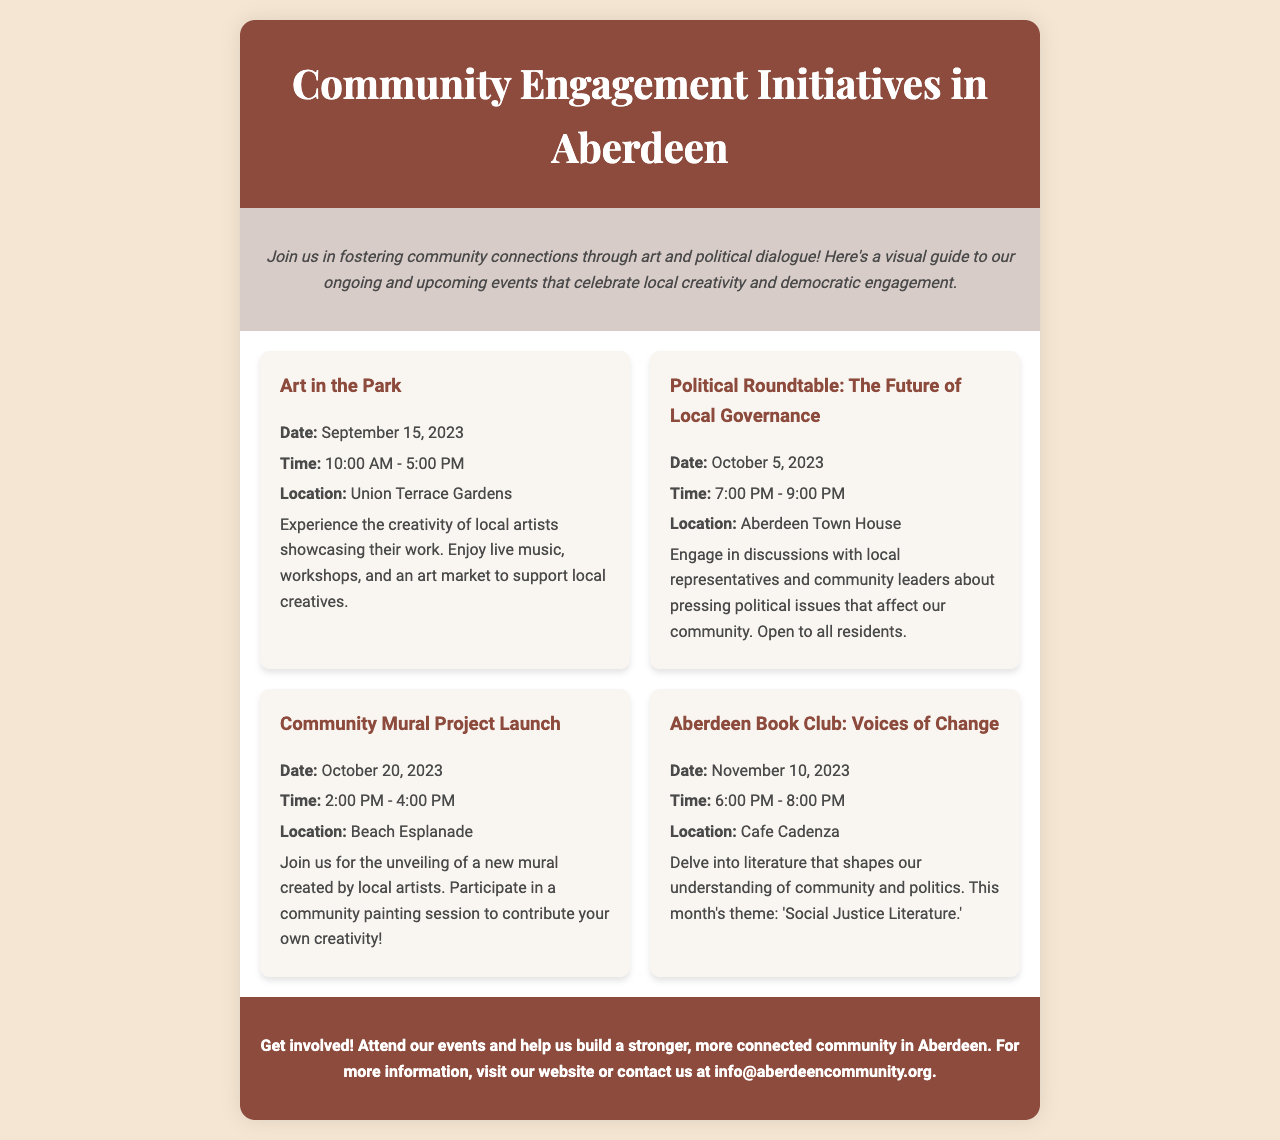what is the date for Art in the Park? The date for Art in the Park is specifically mentioned in the document.
Answer: September 15, 2023 where will the Political Roundtable event take place? The location for the Political Roundtable is stated in the event details.
Answer: Aberdeen Town House what time does the Community Mural Project Launch start? The start time for the Community Mural Project Launch is provided in the document.
Answer: 2:00 PM how many events are listed in the brochure? The total number of events can be counted from the "events" section of the document.
Answer: 4 what is the theme for this month's Aberdeen Book Club? The specific theme for the Aberdeen Book Club is mentioned in the event description.
Answer: Social Justice Literature what can participants do at the Community Mural Project Launch? The document details activities available at the Community Mural Project Launch.
Answer: Participate in a community painting session who can attend the Political Roundtable event? The document mentions the audience for the Political Roundtable event.
Answer: Open to all residents what is the color scheme of the header in the brochure? The document describes the color used in the header section specifically.
Answer: Dark brown what does the introduction encourage people to do? The introduction section of the document outlines the call to action for community members.
Answer: Foster community connections 